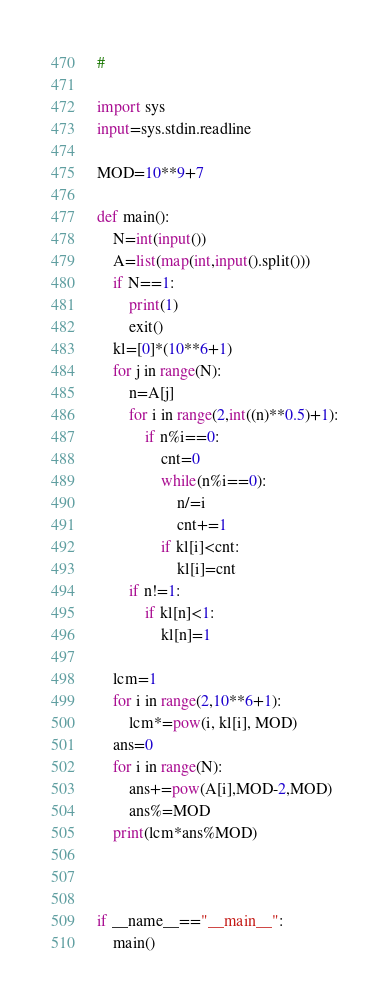Convert code to text. <code><loc_0><loc_0><loc_500><loc_500><_Python_>#

import sys
input=sys.stdin.readline

MOD=10**9+7
            
def main():
    N=int(input())
    A=list(map(int,input().split()))
    if N==1:
        print(1)
        exit()
    kl=[0]*(10**6+1)
    for j in range(N):
        n=A[j]
        for i in range(2,int((n)**0.5)+1):
            if n%i==0:
                cnt=0
                while(n%i==0):
                    n/=i
                    cnt+=1
                if kl[i]<cnt:
                    kl[i]=cnt
        if n!=1:
            if kl[n]<1:
                kl[n]=1
                
    lcm=1
    for i in range(2,10**6+1):
        lcm*=pow(i, kl[i], MOD)
    ans=0
    for i in range(N):
        ans+=pow(A[i],MOD-2,MOD)
        ans%=MOD
    print(lcm*ans%MOD)
    
    
    
if __name__=="__main__":
    main()
</code> 